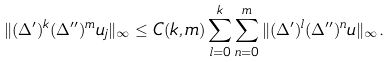<formula> <loc_0><loc_0><loc_500><loc_500>\| ( \Delta ^ { \prime } ) ^ { k } ( \Delta ^ { \prime \prime } ) ^ { m } u _ { j } \| _ { \infty } \leq C ( k , m ) \sum _ { l = 0 } ^ { k } \sum _ { n = 0 } ^ { m } \| ( \Delta ^ { \prime } ) ^ { l } ( \Delta ^ { \prime \prime } ) ^ { n } u \| _ { \infty } .</formula> 